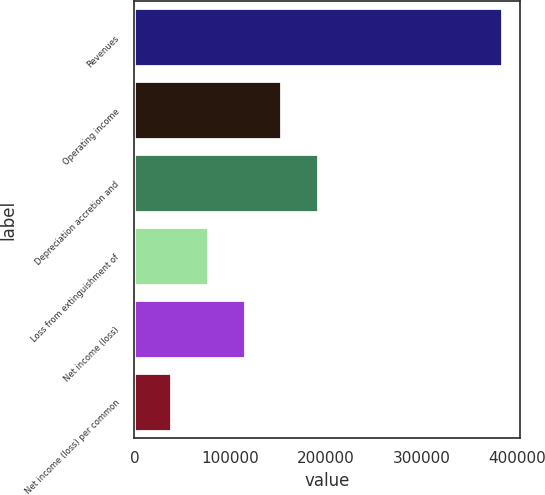Convert chart. <chart><loc_0><loc_0><loc_500><loc_500><bar_chart><fcel>Revenues<fcel>Operating income<fcel>Depreciation accretion and<fcel>Loss from extinguishment of<fcel>Net income (loss)<fcel>Net income (loss) per common<nl><fcel>383420<fcel>153368<fcel>191710<fcel>76684.1<fcel>115026<fcel>38342.1<nl></chart> 